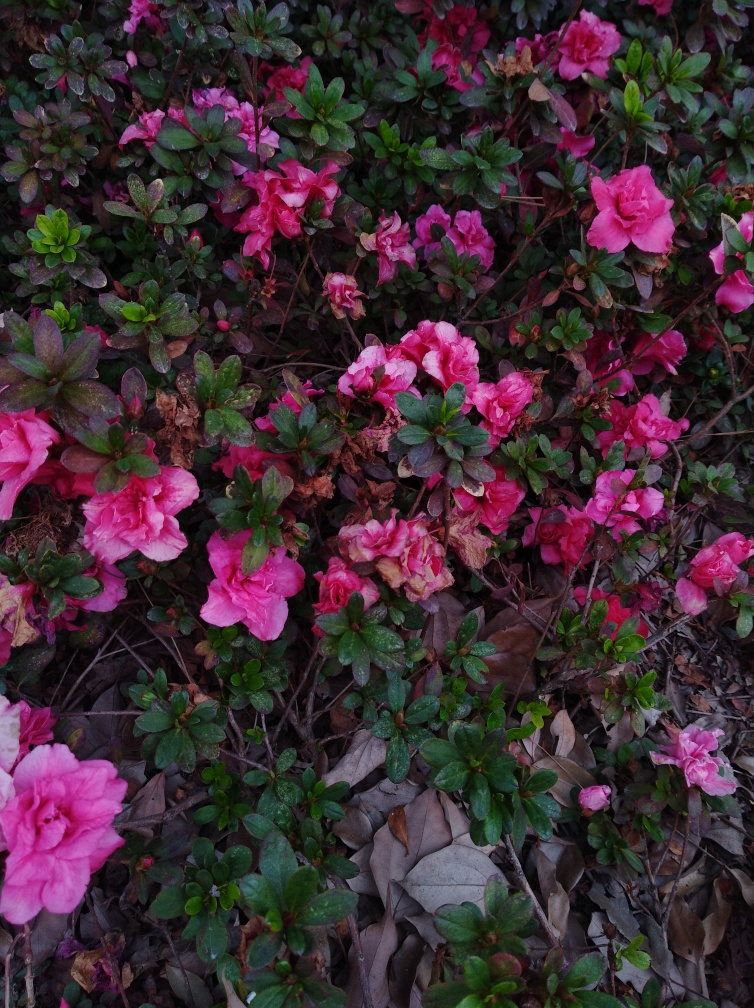Is the quality of the image good?
A. Yes
B. No
Answer with the option's letter from the given choices directly.
 A. 